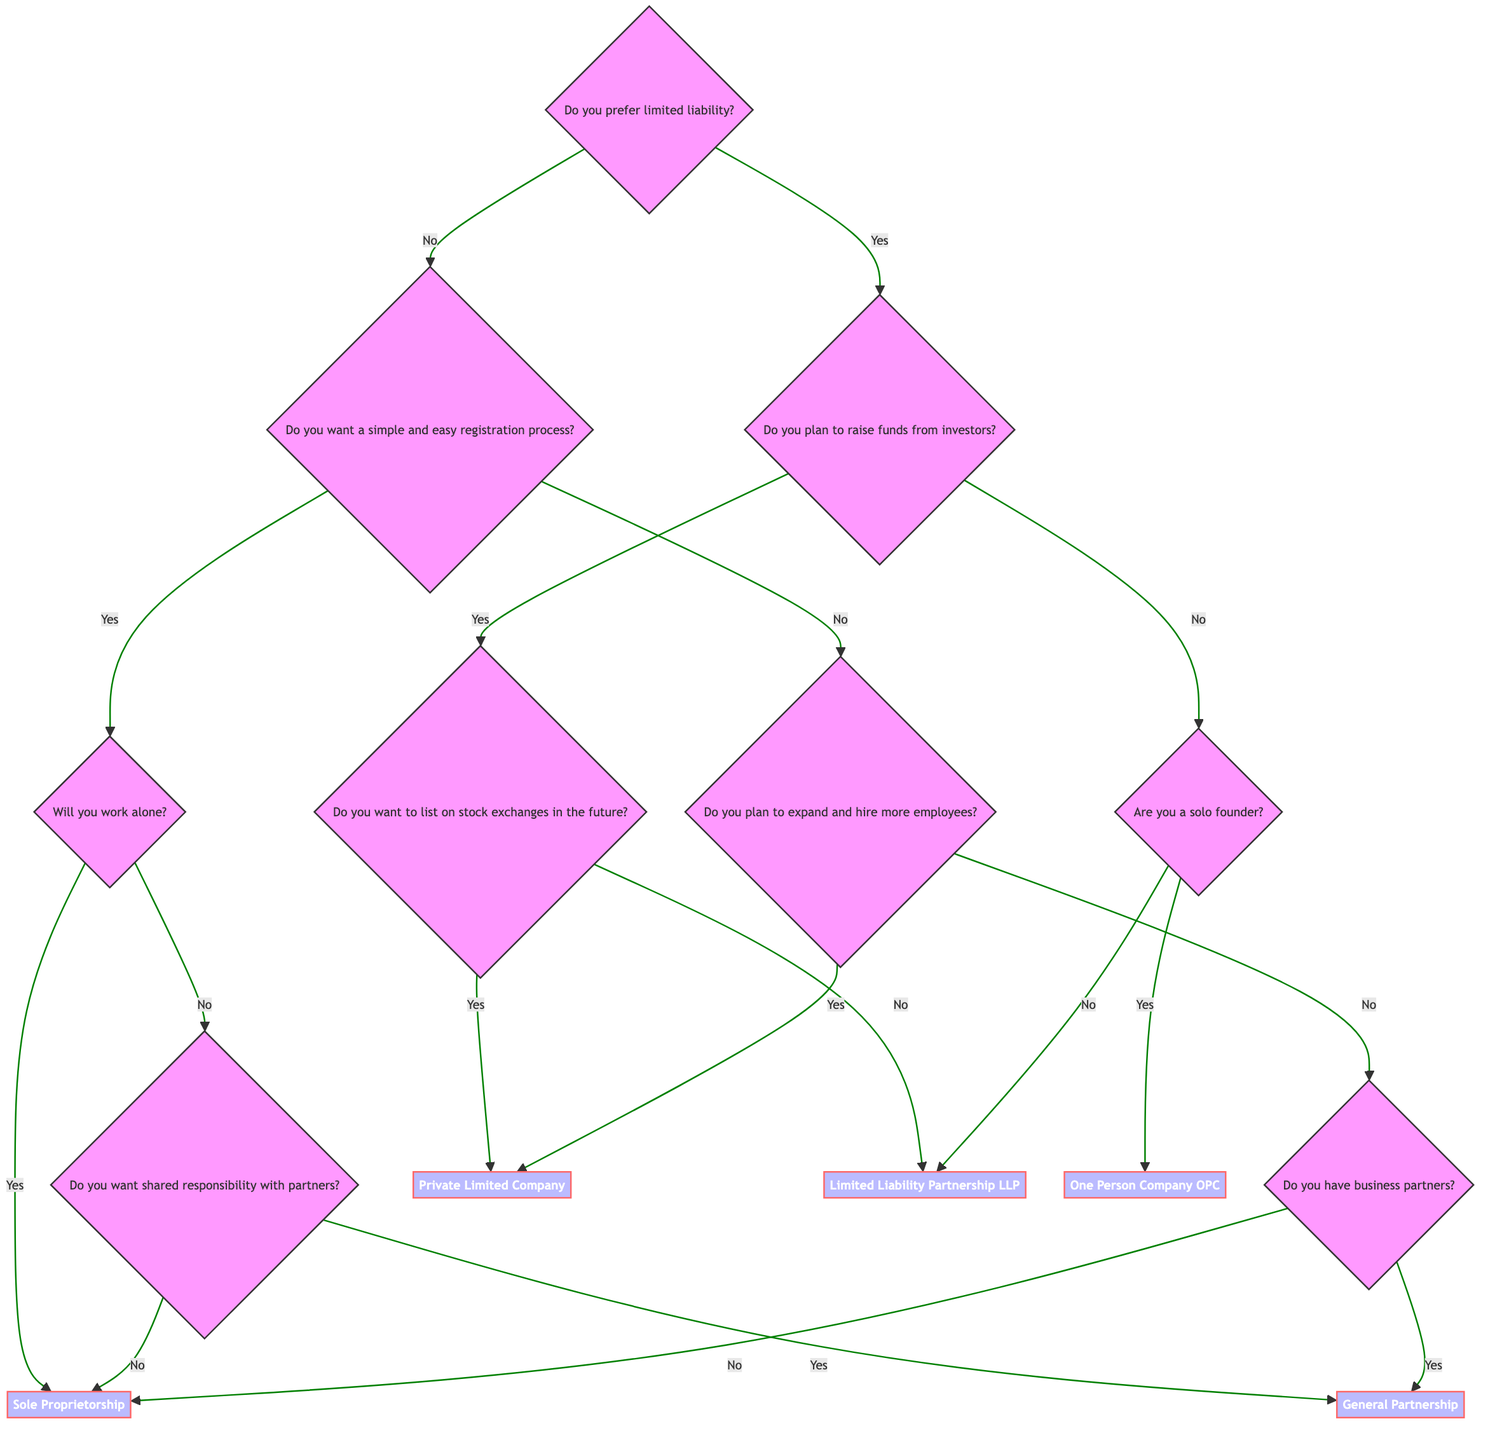What is the first question in the decision tree? The first question, which serves as the starting point for the decision-making process, is "Do you prefer limited liability?"
Answer: Do you prefer limited liability? What are the two options if you prefer limited liability? If you prefer limited liability, the next question is whether you plan to raise funds from investors. This question offers two options: "Yes" and "No."
Answer: Yes and No If you do not prefer limited liability and want a simple registration process, what is the next question? If you do not prefer limited liability and desire a simple registration process, the next question is "Will you work alone?"
Answer: Will you work alone? What conclusion is reached if you plan to raise funds and want to list on stock exchanges? If you plan to raise funds from investors and intend to list on stock exchanges, the conclusion reached is "Private Limited Company."
Answer: Private Limited Company What is the last conclusion for someone who does not prefer limited liability and does not have business partners? If you do not prefer limited liability, do not plan to expand and do not have business partners, the last conclusion is "Sole Proprietorship."
Answer: Sole Proprietorship In total, how many conclusion options are presented in the diagram? The diagram presents five distinct conclusion options, namely: Private Limited Company, Limited Liability Partnership, One Person Company, General Partnership, and Sole Proprietorship.
Answer: Five 